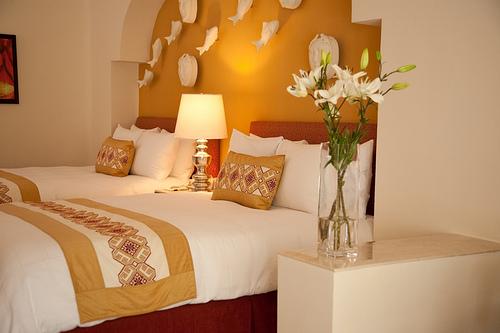What animal is on the walls?
Quick response, please. Fish. Is this a hotel room?
Quick response, please. Yes. Where are the two upside down glasses?
Keep it brief. Nightstand. Is this a hotel?
Answer briefly. Yes. 